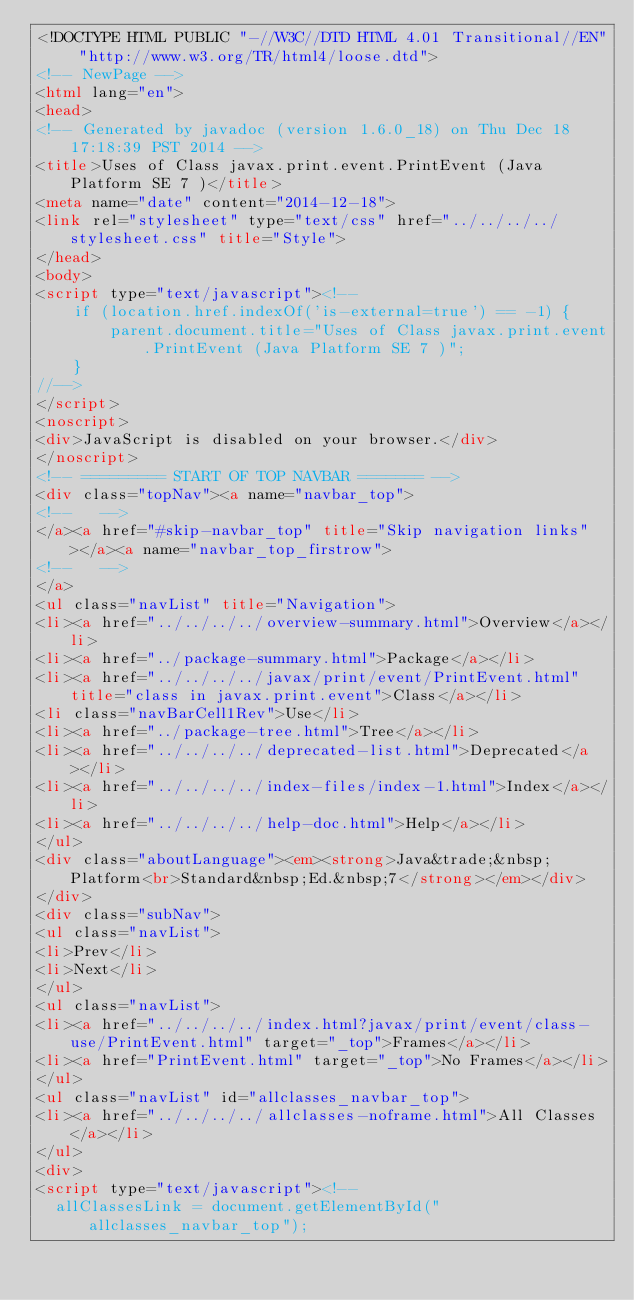<code> <loc_0><loc_0><loc_500><loc_500><_HTML_><!DOCTYPE HTML PUBLIC "-//W3C//DTD HTML 4.01 Transitional//EN" "http://www.w3.org/TR/html4/loose.dtd">
<!-- NewPage -->
<html lang="en">
<head>
<!-- Generated by javadoc (version 1.6.0_18) on Thu Dec 18 17:18:39 PST 2014 -->
<title>Uses of Class javax.print.event.PrintEvent (Java Platform SE 7 )</title>
<meta name="date" content="2014-12-18">
<link rel="stylesheet" type="text/css" href="../../../../stylesheet.css" title="Style">
</head>
<body>
<script type="text/javascript"><!--
    if (location.href.indexOf('is-external=true') == -1) {
        parent.document.title="Uses of Class javax.print.event.PrintEvent (Java Platform SE 7 )";
    }
//-->
</script>
<noscript>
<div>JavaScript is disabled on your browser.</div>
</noscript>
<!-- ========= START OF TOP NAVBAR ======= -->
<div class="topNav"><a name="navbar_top">
<!--   -->
</a><a href="#skip-navbar_top" title="Skip navigation links"></a><a name="navbar_top_firstrow">
<!--   -->
</a>
<ul class="navList" title="Navigation">
<li><a href="../../../../overview-summary.html">Overview</a></li>
<li><a href="../package-summary.html">Package</a></li>
<li><a href="../../../../javax/print/event/PrintEvent.html" title="class in javax.print.event">Class</a></li>
<li class="navBarCell1Rev">Use</li>
<li><a href="../package-tree.html">Tree</a></li>
<li><a href="../../../../deprecated-list.html">Deprecated</a></li>
<li><a href="../../../../index-files/index-1.html">Index</a></li>
<li><a href="../../../../help-doc.html">Help</a></li>
</ul>
<div class="aboutLanguage"><em><strong>Java&trade;&nbsp;Platform<br>Standard&nbsp;Ed.&nbsp;7</strong></em></div>
</div>
<div class="subNav">
<ul class="navList">
<li>Prev</li>
<li>Next</li>
</ul>
<ul class="navList">
<li><a href="../../../../index.html?javax/print/event/class-use/PrintEvent.html" target="_top">Frames</a></li>
<li><a href="PrintEvent.html" target="_top">No Frames</a></li>
</ul>
<ul class="navList" id="allclasses_navbar_top">
<li><a href="../../../../allclasses-noframe.html">All Classes</a></li>
</ul>
<div>
<script type="text/javascript"><!--
  allClassesLink = document.getElementById("allclasses_navbar_top");</code> 